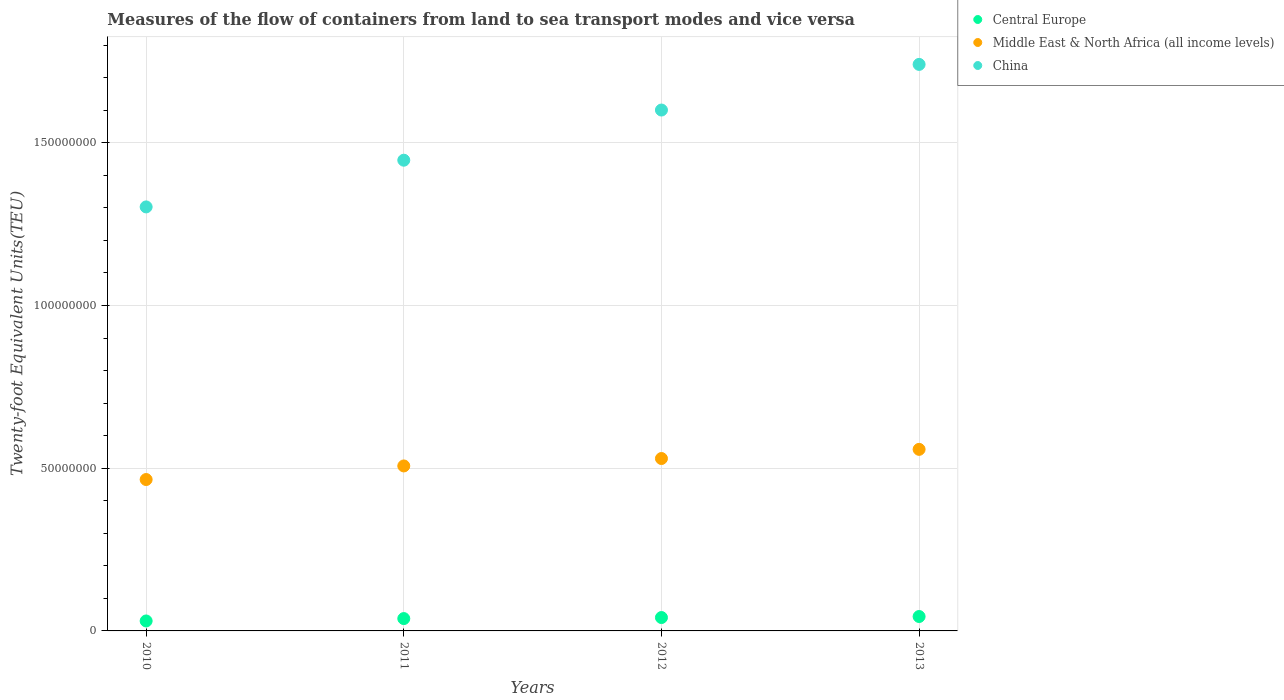How many different coloured dotlines are there?
Offer a very short reply. 3. Is the number of dotlines equal to the number of legend labels?
Your answer should be very brief. Yes. What is the container port traffic in Central Europe in 2012?
Your response must be concise. 4.11e+06. Across all years, what is the maximum container port traffic in Central Europe?
Give a very brief answer. 4.43e+06. Across all years, what is the minimum container port traffic in Central Europe?
Offer a very short reply. 3.06e+06. What is the total container port traffic in China in the graph?
Keep it short and to the point. 6.09e+08. What is the difference between the container port traffic in China in 2010 and that in 2011?
Your answer should be compact. -1.44e+07. What is the difference between the container port traffic in Middle East & North Africa (all income levels) in 2013 and the container port traffic in Central Europe in 2010?
Keep it short and to the point. 5.27e+07. What is the average container port traffic in China per year?
Make the answer very short. 1.52e+08. In the year 2013, what is the difference between the container port traffic in China and container port traffic in Central Europe?
Make the answer very short. 1.70e+08. What is the ratio of the container port traffic in Central Europe in 2011 to that in 2012?
Provide a short and direct response. 0.92. Is the difference between the container port traffic in China in 2011 and 2012 greater than the difference between the container port traffic in Central Europe in 2011 and 2012?
Your answer should be very brief. No. What is the difference between the highest and the second highest container port traffic in Central Europe?
Your answer should be compact. 3.16e+05. What is the difference between the highest and the lowest container port traffic in Central Europe?
Your answer should be compact. 1.36e+06. Is it the case that in every year, the sum of the container port traffic in Central Europe and container port traffic in Middle East & North Africa (all income levels)  is greater than the container port traffic in China?
Provide a succinct answer. No. How many dotlines are there?
Keep it short and to the point. 3. How many years are there in the graph?
Give a very brief answer. 4. Are the values on the major ticks of Y-axis written in scientific E-notation?
Provide a succinct answer. No. Does the graph contain any zero values?
Keep it short and to the point. No. Where does the legend appear in the graph?
Offer a terse response. Top right. How many legend labels are there?
Offer a terse response. 3. What is the title of the graph?
Keep it short and to the point. Measures of the flow of containers from land to sea transport modes and vice versa. Does "Bhutan" appear as one of the legend labels in the graph?
Your response must be concise. No. What is the label or title of the Y-axis?
Provide a short and direct response. Twenty-foot Equivalent Units(TEU). What is the Twenty-foot Equivalent Units(TEU) in Central Europe in 2010?
Offer a terse response. 3.06e+06. What is the Twenty-foot Equivalent Units(TEU) in Middle East & North Africa (all income levels) in 2010?
Offer a terse response. 4.65e+07. What is the Twenty-foot Equivalent Units(TEU) in China in 2010?
Offer a terse response. 1.30e+08. What is the Twenty-foot Equivalent Units(TEU) in Central Europe in 2011?
Offer a terse response. 3.79e+06. What is the Twenty-foot Equivalent Units(TEU) in Middle East & North Africa (all income levels) in 2011?
Your response must be concise. 5.07e+07. What is the Twenty-foot Equivalent Units(TEU) in China in 2011?
Keep it short and to the point. 1.45e+08. What is the Twenty-foot Equivalent Units(TEU) in Central Europe in 2012?
Your answer should be compact. 4.11e+06. What is the Twenty-foot Equivalent Units(TEU) in Middle East & North Africa (all income levels) in 2012?
Offer a terse response. 5.30e+07. What is the Twenty-foot Equivalent Units(TEU) in China in 2012?
Offer a very short reply. 1.60e+08. What is the Twenty-foot Equivalent Units(TEU) of Central Europe in 2013?
Provide a succinct answer. 4.43e+06. What is the Twenty-foot Equivalent Units(TEU) in Middle East & North Africa (all income levels) in 2013?
Ensure brevity in your answer.  5.58e+07. What is the Twenty-foot Equivalent Units(TEU) in China in 2013?
Offer a terse response. 1.74e+08. Across all years, what is the maximum Twenty-foot Equivalent Units(TEU) in Central Europe?
Give a very brief answer. 4.43e+06. Across all years, what is the maximum Twenty-foot Equivalent Units(TEU) of Middle East & North Africa (all income levels)?
Offer a very short reply. 5.58e+07. Across all years, what is the maximum Twenty-foot Equivalent Units(TEU) of China?
Give a very brief answer. 1.74e+08. Across all years, what is the minimum Twenty-foot Equivalent Units(TEU) in Central Europe?
Make the answer very short. 3.06e+06. Across all years, what is the minimum Twenty-foot Equivalent Units(TEU) of Middle East & North Africa (all income levels)?
Ensure brevity in your answer.  4.65e+07. Across all years, what is the minimum Twenty-foot Equivalent Units(TEU) of China?
Ensure brevity in your answer.  1.30e+08. What is the total Twenty-foot Equivalent Units(TEU) in Central Europe in the graph?
Ensure brevity in your answer.  1.54e+07. What is the total Twenty-foot Equivalent Units(TEU) of Middle East & North Africa (all income levels) in the graph?
Your answer should be compact. 2.06e+08. What is the total Twenty-foot Equivalent Units(TEU) in China in the graph?
Provide a succinct answer. 6.09e+08. What is the difference between the Twenty-foot Equivalent Units(TEU) of Central Europe in 2010 and that in 2011?
Keep it short and to the point. -7.32e+05. What is the difference between the Twenty-foot Equivalent Units(TEU) in Middle East & North Africa (all income levels) in 2010 and that in 2011?
Make the answer very short. -4.18e+06. What is the difference between the Twenty-foot Equivalent Units(TEU) of China in 2010 and that in 2011?
Your response must be concise. -1.44e+07. What is the difference between the Twenty-foot Equivalent Units(TEU) of Central Europe in 2010 and that in 2012?
Your response must be concise. -1.05e+06. What is the difference between the Twenty-foot Equivalent Units(TEU) in Middle East & North Africa (all income levels) in 2010 and that in 2012?
Provide a succinct answer. -6.46e+06. What is the difference between the Twenty-foot Equivalent Units(TEU) of China in 2010 and that in 2012?
Give a very brief answer. -2.98e+07. What is the difference between the Twenty-foot Equivalent Units(TEU) of Central Europe in 2010 and that in 2013?
Give a very brief answer. -1.36e+06. What is the difference between the Twenty-foot Equivalent Units(TEU) of Middle East & North Africa (all income levels) in 2010 and that in 2013?
Give a very brief answer. -9.27e+06. What is the difference between the Twenty-foot Equivalent Units(TEU) of China in 2010 and that in 2013?
Give a very brief answer. -4.38e+07. What is the difference between the Twenty-foot Equivalent Units(TEU) of Central Europe in 2011 and that in 2012?
Your response must be concise. -3.17e+05. What is the difference between the Twenty-foot Equivalent Units(TEU) in Middle East & North Africa (all income levels) in 2011 and that in 2012?
Keep it short and to the point. -2.28e+06. What is the difference between the Twenty-foot Equivalent Units(TEU) in China in 2011 and that in 2012?
Give a very brief answer. -1.54e+07. What is the difference between the Twenty-foot Equivalent Units(TEU) in Central Europe in 2011 and that in 2013?
Keep it short and to the point. -6.32e+05. What is the difference between the Twenty-foot Equivalent Units(TEU) of Middle East & North Africa (all income levels) in 2011 and that in 2013?
Your response must be concise. -5.10e+06. What is the difference between the Twenty-foot Equivalent Units(TEU) in China in 2011 and that in 2013?
Ensure brevity in your answer.  -2.94e+07. What is the difference between the Twenty-foot Equivalent Units(TEU) of Central Europe in 2012 and that in 2013?
Offer a very short reply. -3.16e+05. What is the difference between the Twenty-foot Equivalent Units(TEU) of Middle East & North Africa (all income levels) in 2012 and that in 2013?
Offer a very short reply. -2.81e+06. What is the difference between the Twenty-foot Equivalent Units(TEU) of China in 2012 and that in 2013?
Provide a short and direct response. -1.40e+07. What is the difference between the Twenty-foot Equivalent Units(TEU) in Central Europe in 2010 and the Twenty-foot Equivalent Units(TEU) in Middle East & North Africa (all income levels) in 2011?
Make the answer very short. -4.76e+07. What is the difference between the Twenty-foot Equivalent Units(TEU) in Central Europe in 2010 and the Twenty-foot Equivalent Units(TEU) in China in 2011?
Make the answer very short. -1.42e+08. What is the difference between the Twenty-foot Equivalent Units(TEU) in Middle East & North Africa (all income levels) in 2010 and the Twenty-foot Equivalent Units(TEU) in China in 2011?
Provide a succinct answer. -9.81e+07. What is the difference between the Twenty-foot Equivalent Units(TEU) of Central Europe in 2010 and the Twenty-foot Equivalent Units(TEU) of Middle East & North Africa (all income levels) in 2012?
Your answer should be very brief. -4.99e+07. What is the difference between the Twenty-foot Equivalent Units(TEU) of Central Europe in 2010 and the Twenty-foot Equivalent Units(TEU) of China in 2012?
Ensure brevity in your answer.  -1.57e+08. What is the difference between the Twenty-foot Equivalent Units(TEU) of Middle East & North Africa (all income levels) in 2010 and the Twenty-foot Equivalent Units(TEU) of China in 2012?
Ensure brevity in your answer.  -1.14e+08. What is the difference between the Twenty-foot Equivalent Units(TEU) in Central Europe in 2010 and the Twenty-foot Equivalent Units(TEU) in Middle East & North Africa (all income levels) in 2013?
Your answer should be compact. -5.27e+07. What is the difference between the Twenty-foot Equivalent Units(TEU) in Central Europe in 2010 and the Twenty-foot Equivalent Units(TEU) in China in 2013?
Your answer should be very brief. -1.71e+08. What is the difference between the Twenty-foot Equivalent Units(TEU) in Middle East & North Africa (all income levels) in 2010 and the Twenty-foot Equivalent Units(TEU) in China in 2013?
Offer a very short reply. -1.28e+08. What is the difference between the Twenty-foot Equivalent Units(TEU) in Central Europe in 2011 and the Twenty-foot Equivalent Units(TEU) in Middle East & North Africa (all income levels) in 2012?
Your response must be concise. -4.92e+07. What is the difference between the Twenty-foot Equivalent Units(TEU) of Central Europe in 2011 and the Twenty-foot Equivalent Units(TEU) of China in 2012?
Provide a short and direct response. -1.56e+08. What is the difference between the Twenty-foot Equivalent Units(TEU) of Middle East & North Africa (all income levels) in 2011 and the Twenty-foot Equivalent Units(TEU) of China in 2012?
Provide a short and direct response. -1.09e+08. What is the difference between the Twenty-foot Equivalent Units(TEU) of Central Europe in 2011 and the Twenty-foot Equivalent Units(TEU) of Middle East & North Africa (all income levels) in 2013?
Make the answer very short. -5.20e+07. What is the difference between the Twenty-foot Equivalent Units(TEU) in Central Europe in 2011 and the Twenty-foot Equivalent Units(TEU) in China in 2013?
Provide a short and direct response. -1.70e+08. What is the difference between the Twenty-foot Equivalent Units(TEU) of Middle East & North Africa (all income levels) in 2011 and the Twenty-foot Equivalent Units(TEU) of China in 2013?
Provide a short and direct response. -1.23e+08. What is the difference between the Twenty-foot Equivalent Units(TEU) of Central Europe in 2012 and the Twenty-foot Equivalent Units(TEU) of Middle East & North Africa (all income levels) in 2013?
Your answer should be very brief. -5.17e+07. What is the difference between the Twenty-foot Equivalent Units(TEU) of Central Europe in 2012 and the Twenty-foot Equivalent Units(TEU) of China in 2013?
Provide a short and direct response. -1.70e+08. What is the difference between the Twenty-foot Equivalent Units(TEU) of Middle East & North Africa (all income levels) in 2012 and the Twenty-foot Equivalent Units(TEU) of China in 2013?
Your answer should be compact. -1.21e+08. What is the average Twenty-foot Equivalent Units(TEU) in Central Europe per year?
Keep it short and to the point. 3.85e+06. What is the average Twenty-foot Equivalent Units(TEU) of Middle East & North Africa (all income levels) per year?
Offer a terse response. 5.15e+07. What is the average Twenty-foot Equivalent Units(TEU) in China per year?
Ensure brevity in your answer.  1.52e+08. In the year 2010, what is the difference between the Twenty-foot Equivalent Units(TEU) of Central Europe and Twenty-foot Equivalent Units(TEU) of Middle East & North Africa (all income levels)?
Give a very brief answer. -4.35e+07. In the year 2010, what is the difference between the Twenty-foot Equivalent Units(TEU) in Central Europe and Twenty-foot Equivalent Units(TEU) in China?
Make the answer very short. -1.27e+08. In the year 2010, what is the difference between the Twenty-foot Equivalent Units(TEU) in Middle East & North Africa (all income levels) and Twenty-foot Equivalent Units(TEU) in China?
Your response must be concise. -8.38e+07. In the year 2011, what is the difference between the Twenty-foot Equivalent Units(TEU) of Central Europe and Twenty-foot Equivalent Units(TEU) of Middle East & North Africa (all income levels)?
Provide a short and direct response. -4.69e+07. In the year 2011, what is the difference between the Twenty-foot Equivalent Units(TEU) of Central Europe and Twenty-foot Equivalent Units(TEU) of China?
Provide a succinct answer. -1.41e+08. In the year 2011, what is the difference between the Twenty-foot Equivalent Units(TEU) of Middle East & North Africa (all income levels) and Twenty-foot Equivalent Units(TEU) of China?
Make the answer very short. -9.39e+07. In the year 2012, what is the difference between the Twenty-foot Equivalent Units(TEU) in Central Europe and Twenty-foot Equivalent Units(TEU) in Middle East & North Africa (all income levels)?
Make the answer very short. -4.89e+07. In the year 2012, what is the difference between the Twenty-foot Equivalent Units(TEU) in Central Europe and Twenty-foot Equivalent Units(TEU) in China?
Your answer should be very brief. -1.56e+08. In the year 2012, what is the difference between the Twenty-foot Equivalent Units(TEU) in Middle East & North Africa (all income levels) and Twenty-foot Equivalent Units(TEU) in China?
Keep it short and to the point. -1.07e+08. In the year 2013, what is the difference between the Twenty-foot Equivalent Units(TEU) in Central Europe and Twenty-foot Equivalent Units(TEU) in Middle East & North Africa (all income levels)?
Provide a succinct answer. -5.14e+07. In the year 2013, what is the difference between the Twenty-foot Equivalent Units(TEU) of Central Europe and Twenty-foot Equivalent Units(TEU) of China?
Ensure brevity in your answer.  -1.70e+08. In the year 2013, what is the difference between the Twenty-foot Equivalent Units(TEU) of Middle East & North Africa (all income levels) and Twenty-foot Equivalent Units(TEU) of China?
Offer a terse response. -1.18e+08. What is the ratio of the Twenty-foot Equivalent Units(TEU) of Central Europe in 2010 to that in 2011?
Ensure brevity in your answer.  0.81. What is the ratio of the Twenty-foot Equivalent Units(TEU) of Middle East & North Africa (all income levels) in 2010 to that in 2011?
Keep it short and to the point. 0.92. What is the ratio of the Twenty-foot Equivalent Units(TEU) in China in 2010 to that in 2011?
Offer a very short reply. 0.9. What is the ratio of the Twenty-foot Equivalent Units(TEU) of Central Europe in 2010 to that in 2012?
Provide a succinct answer. 0.74. What is the ratio of the Twenty-foot Equivalent Units(TEU) of Middle East & North Africa (all income levels) in 2010 to that in 2012?
Keep it short and to the point. 0.88. What is the ratio of the Twenty-foot Equivalent Units(TEU) in China in 2010 to that in 2012?
Offer a very short reply. 0.81. What is the ratio of the Twenty-foot Equivalent Units(TEU) in Central Europe in 2010 to that in 2013?
Make the answer very short. 0.69. What is the ratio of the Twenty-foot Equivalent Units(TEU) in Middle East & North Africa (all income levels) in 2010 to that in 2013?
Your answer should be very brief. 0.83. What is the ratio of the Twenty-foot Equivalent Units(TEU) in China in 2010 to that in 2013?
Give a very brief answer. 0.75. What is the ratio of the Twenty-foot Equivalent Units(TEU) of Central Europe in 2011 to that in 2012?
Provide a succinct answer. 0.92. What is the ratio of the Twenty-foot Equivalent Units(TEU) of Middle East & North Africa (all income levels) in 2011 to that in 2012?
Keep it short and to the point. 0.96. What is the ratio of the Twenty-foot Equivalent Units(TEU) of China in 2011 to that in 2012?
Give a very brief answer. 0.9. What is the ratio of the Twenty-foot Equivalent Units(TEU) in Central Europe in 2011 to that in 2013?
Give a very brief answer. 0.86. What is the ratio of the Twenty-foot Equivalent Units(TEU) of Middle East & North Africa (all income levels) in 2011 to that in 2013?
Keep it short and to the point. 0.91. What is the ratio of the Twenty-foot Equivalent Units(TEU) in China in 2011 to that in 2013?
Offer a very short reply. 0.83. What is the ratio of the Twenty-foot Equivalent Units(TEU) in Central Europe in 2012 to that in 2013?
Offer a terse response. 0.93. What is the ratio of the Twenty-foot Equivalent Units(TEU) of Middle East & North Africa (all income levels) in 2012 to that in 2013?
Keep it short and to the point. 0.95. What is the ratio of the Twenty-foot Equivalent Units(TEU) of China in 2012 to that in 2013?
Ensure brevity in your answer.  0.92. What is the difference between the highest and the second highest Twenty-foot Equivalent Units(TEU) in Central Europe?
Your response must be concise. 3.16e+05. What is the difference between the highest and the second highest Twenty-foot Equivalent Units(TEU) of Middle East & North Africa (all income levels)?
Offer a very short reply. 2.81e+06. What is the difference between the highest and the second highest Twenty-foot Equivalent Units(TEU) of China?
Make the answer very short. 1.40e+07. What is the difference between the highest and the lowest Twenty-foot Equivalent Units(TEU) in Central Europe?
Make the answer very short. 1.36e+06. What is the difference between the highest and the lowest Twenty-foot Equivalent Units(TEU) of Middle East & North Africa (all income levels)?
Your response must be concise. 9.27e+06. What is the difference between the highest and the lowest Twenty-foot Equivalent Units(TEU) in China?
Provide a succinct answer. 4.38e+07. 